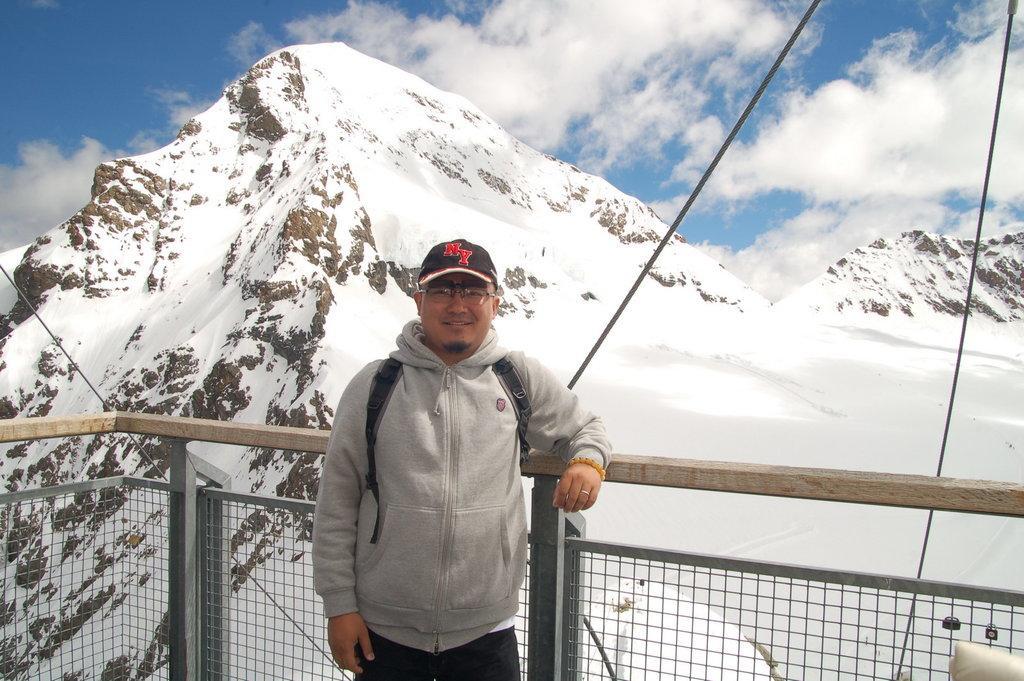In one or two sentences, can you explain what this image depicts? In this image, in the middle, we can see a man wearing a backpack is standing. In the background, we can see metal fence, wood rod, rope. In the background, we can also see some mountains which are covered with snow. At the top, we can see a sky which is a bit cloudy. 